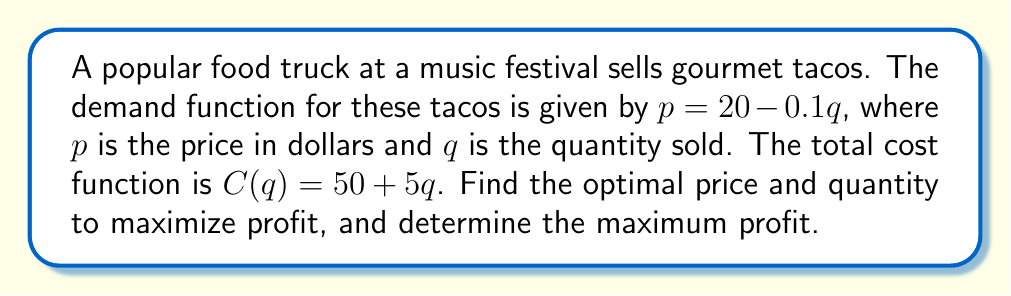Solve this math problem. To find the optimal pricing strategy, we need to use marginal revenue and marginal cost.

Step 1: Find the revenue function
$R(q) = pq = (20 - 0.1q)q = 20q - 0.1q^2$

Step 2: Find the marginal revenue function
$MR(q) = \frac{dR}{dq} = 20 - 0.2q$

Step 3: Find the marginal cost function
$MC(q) = \frac{dC}{dq} = 5$

Step 4: Set MR = MC to find the optimal quantity
$20 - 0.2q = 5$
$15 = 0.2q$
$q = 75$ tacos

Step 5: Find the optimal price by substituting q into the demand function
$p = 20 - 0.1(75) = 12.50$

Step 6: Calculate the maximum profit
$\pi = R(q) - C(q)$
$\pi = (12.50 \times 75) - (50 + 5 \times 75)$
$\pi = 937.50 - 425 = 512.50$

Therefore, the optimal price is $12.50, the optimal quantity is 75 tacos, and the maximum profit is $512.50.
Answer: Price: $12.50, Quantity: 75 tacos, Maximum profit: $512.50 